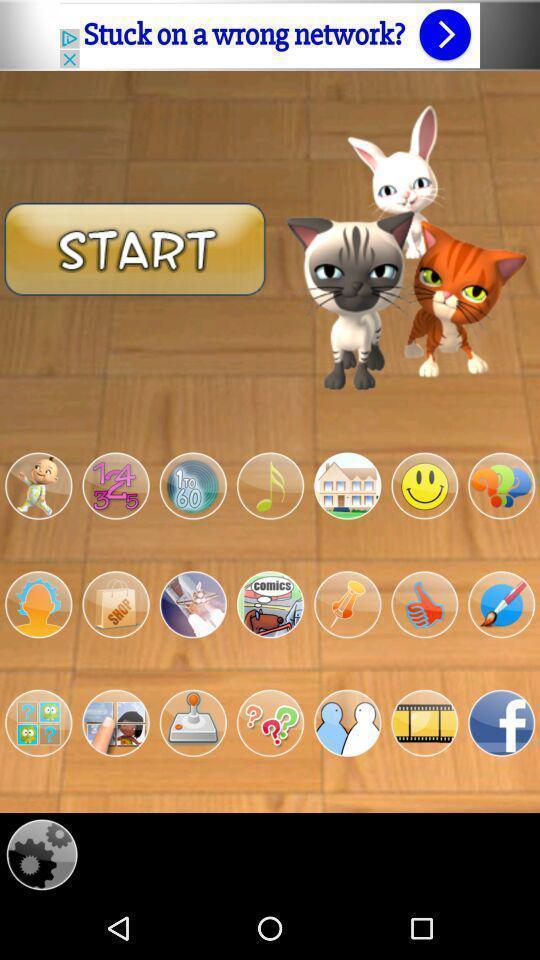What is the overall content of this screenshot? Start up option of the game. 